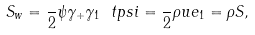Convert formula to latex. <formula><loc_0><loc_0><loc_500><loc_500>S _ { w } = \frac { } { 2 } \psi \gamma _ { + } \gamma _ { 1 } \ t p s i = \frac { } { 2 } \rho u e _ { 1 } = \rho S ,</formula> 